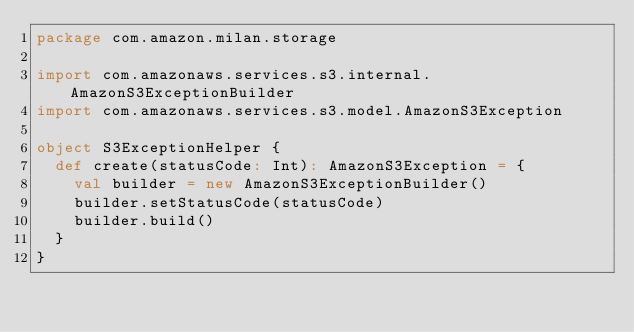Convert code to text. <code><loc_0><loc_0><loc_500><loc_500><_Scala_>package com.amazon.milan.storage

import com.amazonaws.services.s3.internal.AmazonS3ExceptionBuilder
import com.amazonaws.services.s3.model.AmazonS3Exception

object S3ExceptionHelper {
  def create(statusCode: Int): AmazonS3Exception = {
    val builder = new AmazonS3ExceptionBuilder()
    builder.setStatusCode(statusCode)
    builder.build()
  }
}
</code> 